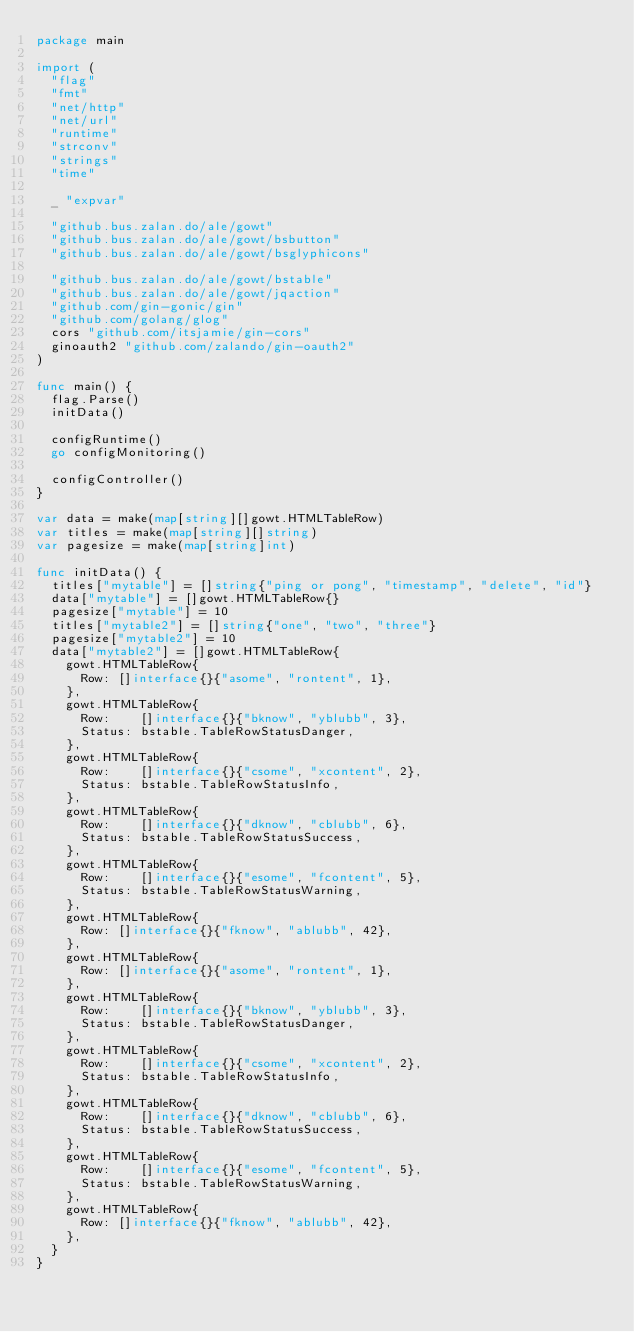Convert code to text. <code><loc_0><loc_0><loc_500><loc_500><_Go_>package main

import (
	"flag"
	"fmt"
	"net/http"
	"net/url"
	"runtime"
	"strconv"
	"strings"
	"time"

	_ "expvar"

	"github.bus.zalan.do/ale/gowt"
	"github.bus.zalan.do/ale/gowt/bsbutton"
	"github.bus.zalan.do/ale/gowt/bsglyphicons"

	"github.bus.zalan.do/ale/gowt/bstable"
	"github.bus.zalan.do/ale/gowt/jqaction"
	"github.com/gin-gonic/gin"
	"github.com/golang/glog"
	cors "github.com/itsjamie/gin-cors"
	ginoauth2 "github.com/zalando/gin-oauth2"
)

func main() {
	flag.Parse()
	initData()

	configRuntime()
	go configMonitoring()

	configController()
}

var data = make(map[string][]gowt.HTMLTableRow)
var titles = make(map[string][]string)
var pagesize = make(map[string]int)

func initData() {
	titles["mytable"] = []string{"ping or pong", "timestamp", "delete", "id"}
	data["mytable"] = []gowt.HTMLTableRow{}
	pagesize["mytable"] = 10
	titles["mytable2"] = []string{"one", "two", "three"}
	pagesize["mytable2"] = 10
	data["mytable2"] = []gowt.HTMLTableRow{
		gowt.HTMLTableRow{
			Row: []interface{}{"asome", "rontent", 1},
		},
		gowt.HTMLTableRow{
			Row:    []interface{}{"bknow", "yblubb", 3},
			Status: bstable.TableRowStatusDanger,
		},
		gowt.HTMLTableRow{
			Row:    []interface{}{"csome", "xcontent", 2},
			Status: bstable.TableRowStatusInfo,
		},
		gowt.HTMLTableRow{
			Row:    []interface{}{"dknow", "cblubb", 6},
			Status: bstable.TableRowStatusSuccess,
		},
		gowt.HTMLTableRow{
			Row:    []interface{}{"esome", "fcontent", 5},
			Status: bstable.TableRowStatusWarning,
		},
		gowt.HTMLTableRow{
			Row: []interface{}{"fknow", "ablubb", 42},
		},
		gowt.HTMLTableRow{
			Row: []interface{}{"asome", "rontent", 1},
		},
		gowt.HTMLTableRow{
			Row:    []interface{}{"bknow", "yblubb", 3},
			Status: bstable.TableRowStatusDanger,
		},
		gowt.HTMLTableRow{
			Row:    []interface{}{"csome", "xcontent", 2},
			Status: bstable.TableRowStatusInfo,
		},
		gowt.HTMLTableRow{
			Row:    []interface{}{"dknow", "cblubb", 6},
			Status: bstable.TableRowStatusSuccess,
		},
		gowt.HTMLTableRow{
			Row:    []interface{}{"esome", "fcontent", 5},
			Status: bstable.TableRowStatusWarning,
		},
		gowt.HTMLTableRow{
			Row: []interface{}{"fknow", "ablubb", 42},
		},
	}
}
</code> 